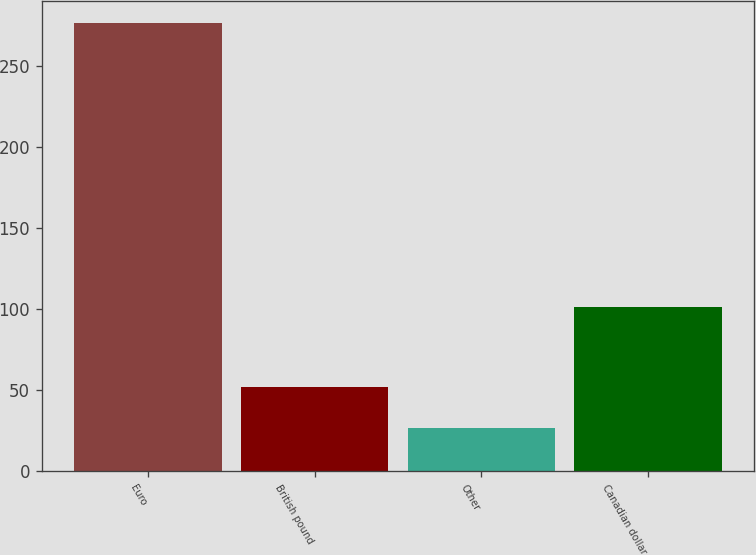<chart> <loc_0><loc_0><loc_500><loc_500><bar_chart><fcel>Euro<fcel>British pound<fcel>Other<fcel>Canadian dollar<nl><fcel>276.2<fcel>51.56<fcel>26.6<fcel>101.3<nl></chart> 